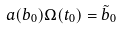Convert formula to latex. <formula><loc_0><loc_0><loc_500><loc_500>a ( b _ { 0 } ) \Omega ( t _ { 0 } ) = \tilde { b } _ { 0 }</formula> 